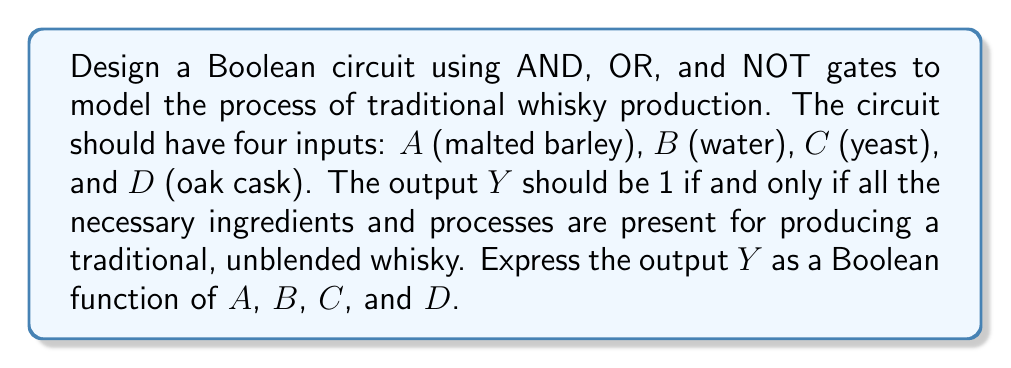Give your solution to this math problem. Let's approach this step-by-step:

1) For traditional whisky production, we need all four elements: malted barley, water, yeast, and an oak cask for aging.

2) In Boolean terms, this means we need all inputs to be 1 (present) for the output to be 1 (traditional whisky produced).

3) This scenario is perfectly modeled by an AND gate with four inputs.

4) The Boolean function for a 4-input AND gate is:

   $$Y = A \cdot B \cdot C \cdot D$$

5) To represent this as a circuit:

   [asy]
   import geometry;

   // Drawing AND gate
   path p = (0,0)--(0,40)--(20,40)..controls (40,40) and (40,0)..(20,0)--cycle;
   draw(p);
   
   // Inputs
   draw((-20,35)--(0,35));
   draw((-20,25)--(0,25));
   draw((-20,15)--(0,15));
   draw((-20,5)--(0,5));
   
   // Output
   draw((40,20)--(60,20));
   
   // Labels
   label("A", (-25,35));
   label("B", (-25,25));
   label("C", (-25,15));
   label("D", (-25,5));
   label("Y", (65,20));
   label("&", (10,20));
   [/asy]

6) This circuit will output 1 (true) only when all inputs A, B, C, and D are 1 (present), which accurately models the traditional whisky production process.
Answer: $$Y = A \cdot B \cdot C \cdot D$$ 